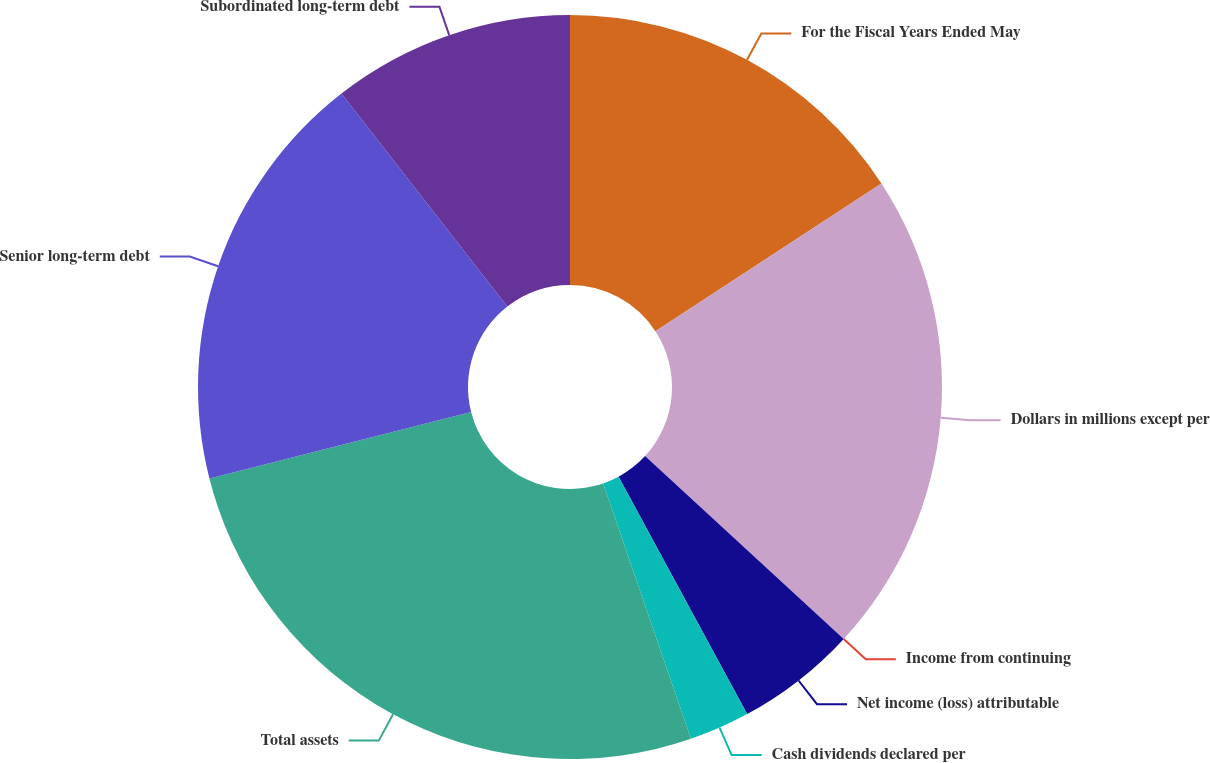Convert chart. <chart><loc_0><loc_0><loc_500><loc_500><pie_chart><fcel>For the Fiscal Years Ended May<fcel>Dollars in millions except per<fcel>Income from continuing<fcel>Net income (loss) attributable<fcel>Cash dividends declared per<fcel>Total assets<fcel>Senior long-term debt<fcel>Subordinated long-term debt<nl><fcel>15.79%<fcel>21.05%<fcel>0.0%<fcel>5.26%<fcel>2.63%<fcel>26.32%<fcel>18.42%<fcel>10.53%<nl></chart> 